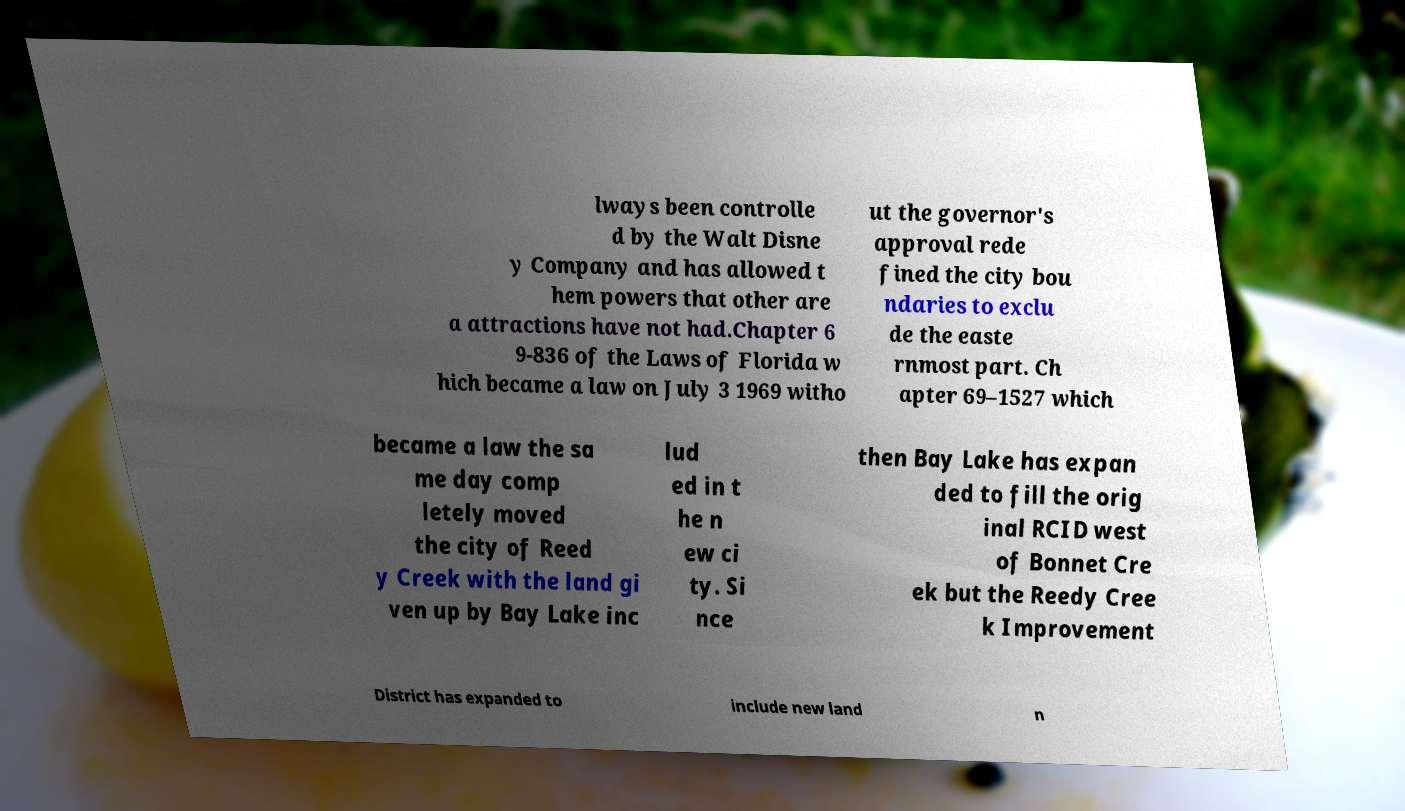For documentation purposes, I need the text within this image transcribed. Could you provide that? lways been controlle d by the Walt Disne y Company and has allowed t hem powers that other are a attractions have not had.Chapter 6 9-836 of the Laws of Florida w hich became a law on July 3 1969 witho ut the governor's approval rede fined the city bou ndaries to exclu de the easte rnmost part. Ch apter 69–1527 which became a law the sa me day comp letely moved the city of Reed y Creek with the land gi ven up by Bay Lake inc lud ed in t he n ew ci ty. Si nce then Bay Lake has expan ded to fill the orig inal RCID west of Bonnet Cre ek but the Reedy Cree k Improvement District has expanded to include new land n 